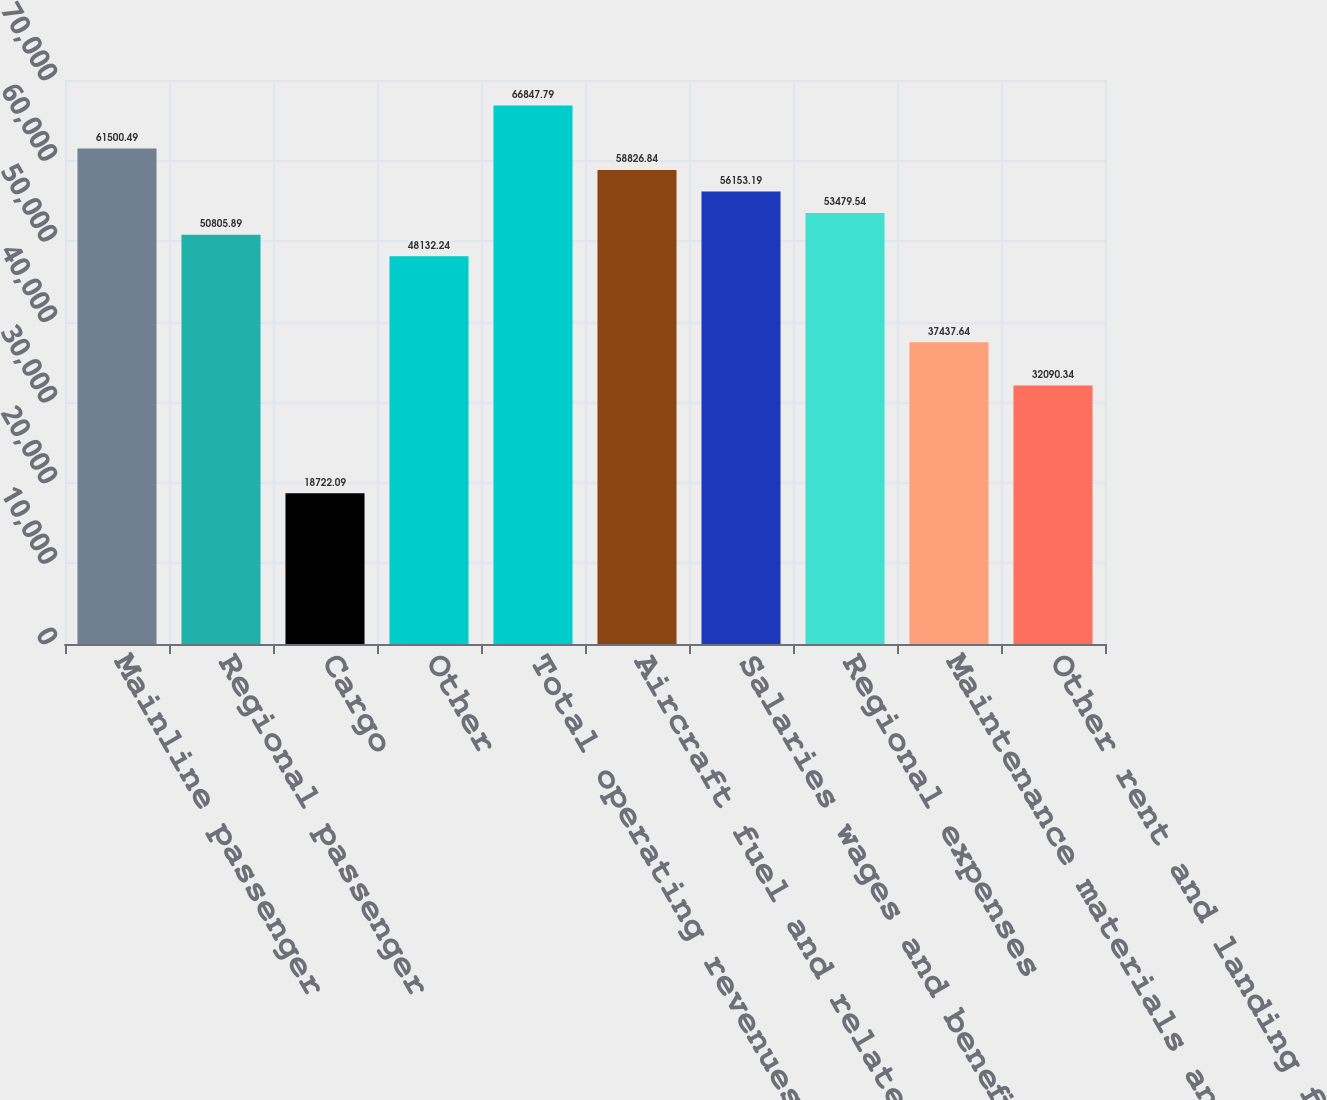<chart> <loc_0><loc_0><loc_500><loc_500><bar_chart><fcel>Mainline passenger<fcel>Regional passenger<fcel>Cargo<fcel>Other<fcel>Total operating revenues<fcel>Aircraft fuel and related<fcel>Salaries wages and benefits<fcel>Regional expenses<fcel>Maintenance materials and<fcel>Other rent and landing fees<nl><fcel>61500.5<fcel>50805.9<fcel>18722.1<fcel>48132.2<fcel>66847.8<fcel>58826.8<fcel>56153.2<fcel>53479.5<fcel>37437.6<fcel>32090.3<nl></chart> 